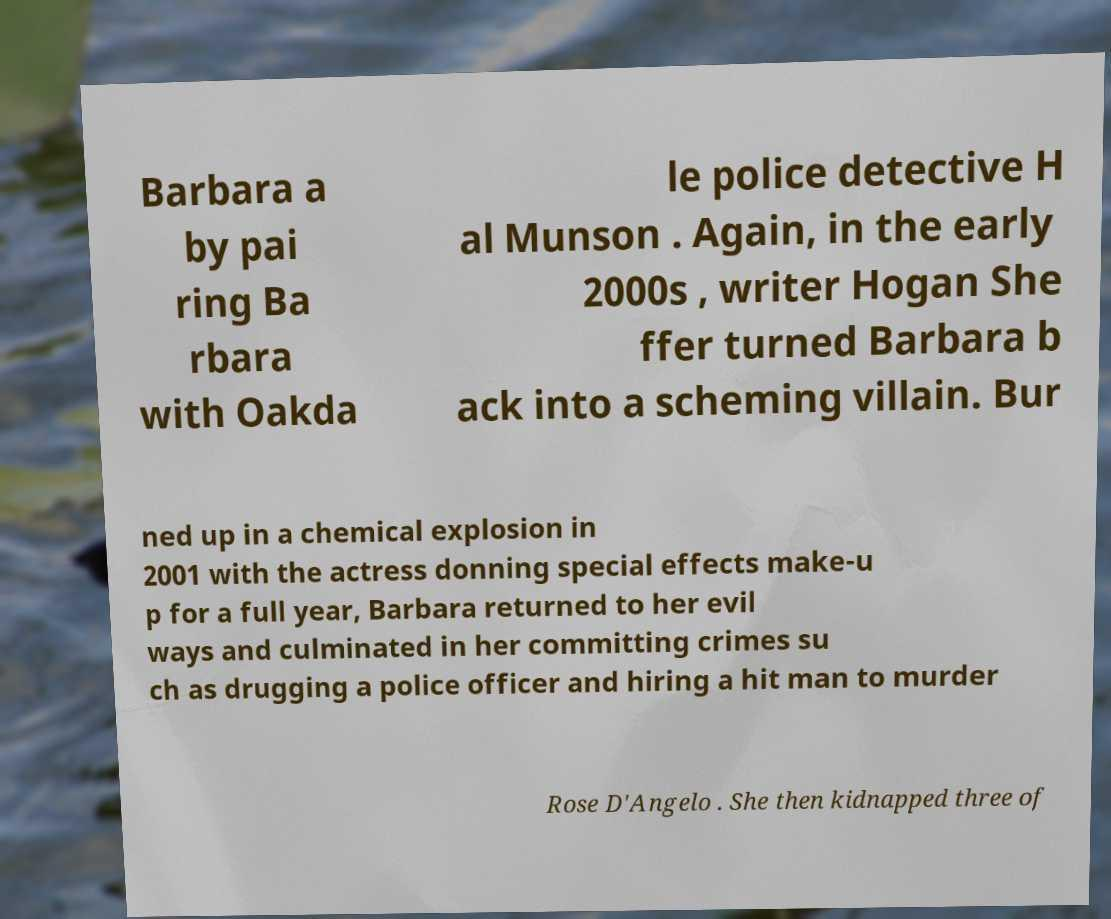For documentation purposes, I need the text within this image transcribed. Could you provide that? Barbara a by pai ring Ba rbara with Oakda le police detective H al Munson . Again, in the early 2000s , writer Hogan She ffer turned Barbara b ack into a scheming villain. Bur ned up in a chemical explosion in 2001 with the actress donning special effects make-u p for a full year, Barbara returned to her evil ways and culminated in her committing crimes su ch as drugging a police officer and hiring a hit man to murder Rose D'Angelo . She then kidnapped three of 